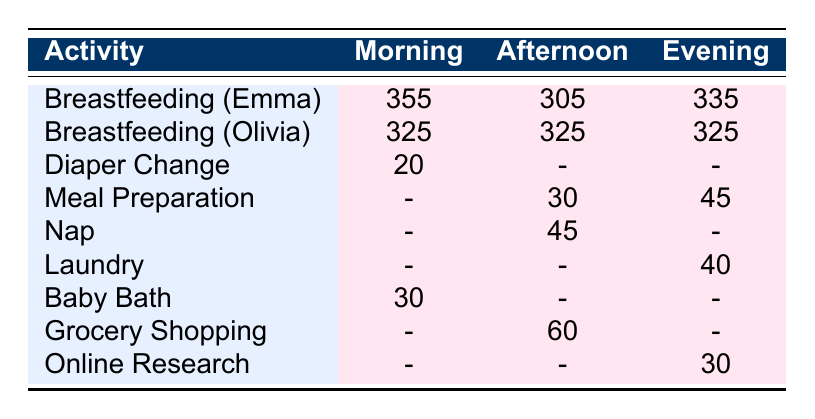What is the total time spent breastfeeding Emma in the morning? In the table, the time spent breastfeeding Emma in the morning is listed as 355 minutes.
Answer: 355 How many minutes did Olivia spend breastfeeding in the afternoon? The table shows that Olivia spent 325 minutes breastfeeding in the afternoon.
Answer: 325 Which activity has the shortest duration recorded in the morning? The only activity listed in the morning that is not breastfeeding is diaper change, which has a duration of 20 minutes, the lowest value in that column.
Answer: 20 What is the total duration of breastfeeding for both twins combined in the evening? For the evening, Emma spent 335 minutes breastfeeding, and Olivia spent 325 minutes. Adding them together gives 335 + 325 = 660 minutes.
Answer: 660 Did more time get allocated to meal preparation in the afternoon or evening? In the afternoon, meal preparation is listed as 30 minutes and in the evening as 45 minutes. Since 45 minutes is greater than 30 minutes, more time was allocated to meal preparation in the evening.
Answer: Yes What was the average duration spent on diaper change and baby bath in the morning? Diaper change was 20 minutes and baby bath was 30 minutes. The average is calculated as (20 + 30) / 2 = 25 minutes.
Answer: 25 Is the time spent on laundry in the evening greater than the time spent on grocery shopping in the afternoon? The table lists laundry in the evening as 40 minutes and grocery shopping in the afternoon as 60 minutes. Since 40 is less than 60, the statement is false.
Answer: No What is the combined time spent on naps and laundry across all time periods? The table shows a nap duration of 45 minutes in the afternoon and laundry of 40 minutes in the evening. The total combined time is 45 + 40 = 85 minutes.
Answer: 85 How many total minutes were dedicated to breastfeeding across all times of the day for Olivia? The table shows Olivia's breastfeeding duration as 325 minutes in the morning, 325 in the afternoon, and 325 in the evening. Adding these gives 325 + 325 + 325 = 975 minutes.
Answer: 975 